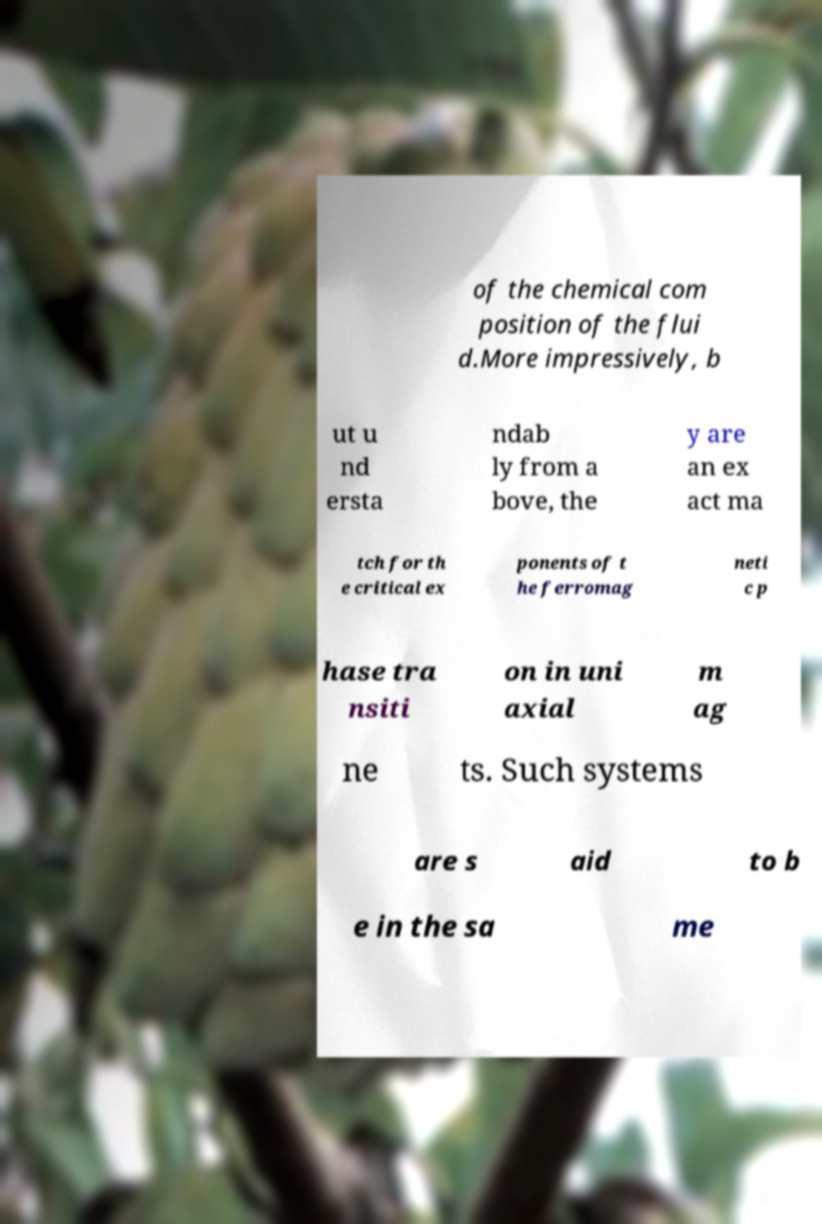Please identify and transcribe the text found in this image. of the chemical com position of the flui d.More impressively, b ut u nd ersta ndab ly from a bove, the y are an ex act ma tch for th e critical ex ponents of t he ferromag neti c p hase tra nsiti on in uni axial m ag ne ts. Such systems are s aid to b e in the sa me 